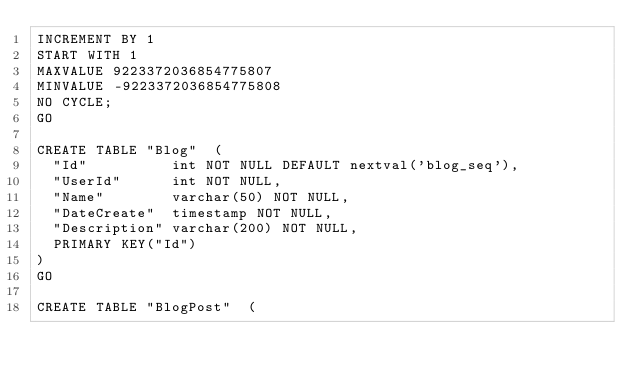Convert code to text. <code><loc_0><loc_0><loc_500><loc_500><_SQL_>INCREMENT BY 1
START WITH 1
MAXVALUE 9223372036854775807
MINVALUE -9223372036854775808
NO CYCLE;
GO

CREATE TABLE "Blog"  ( 
	"Id"         	int NOT NULL DEFAULT nextval('blog_seq'),
	"UserId"     	int NOT NULL,
	"Name"       	varchar(50) NOT NULL,
	"DateCreate" 	timestamp NOT NULL,
	"Description"	varchar(200) NOT NULL,
	PRIMARY KEY("Id")
)
GO

CREATE TABLE "BlogPost"  ( </code> 